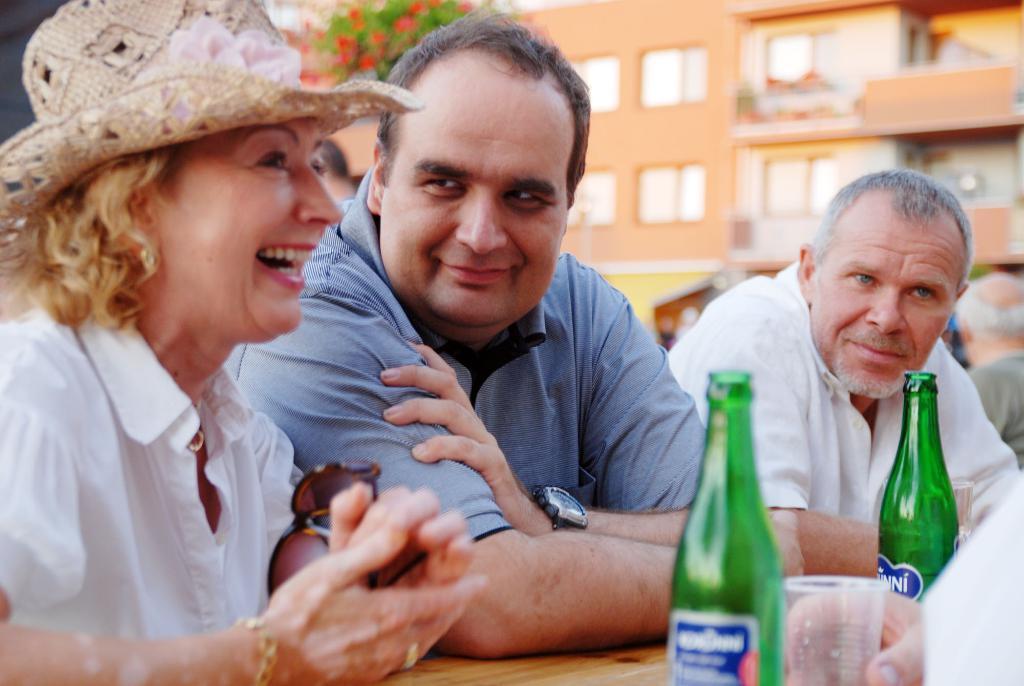Can you describe this image briefly? In this picture we can see three persons are sitting on the chairs. She is smiling and she wear a hat. This is table. On the table there is a glass, and bottles. On the background we can see a building and this is plant. And there are red color flowers. 